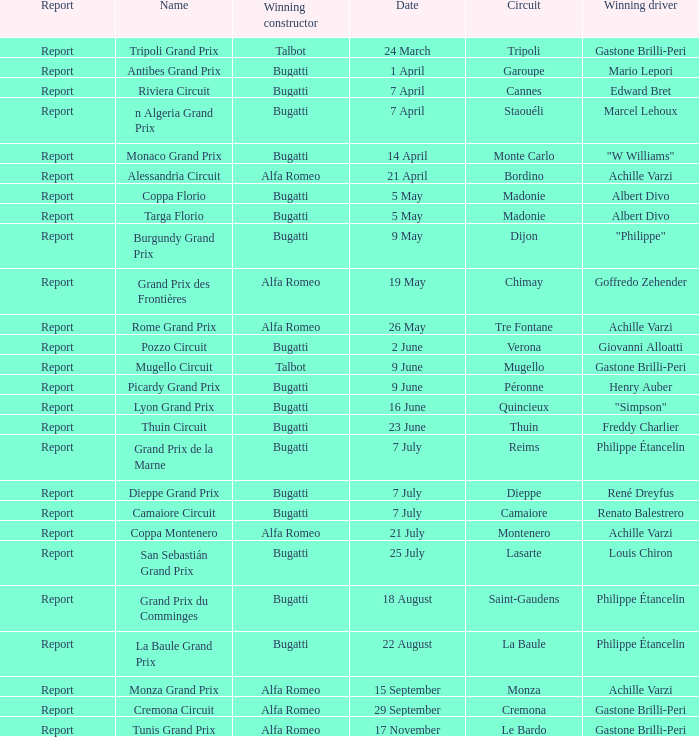What Name has a Winning constructor of bugatti, and a Winning driver of louis chiron? San Sebastián Grand Prix. 